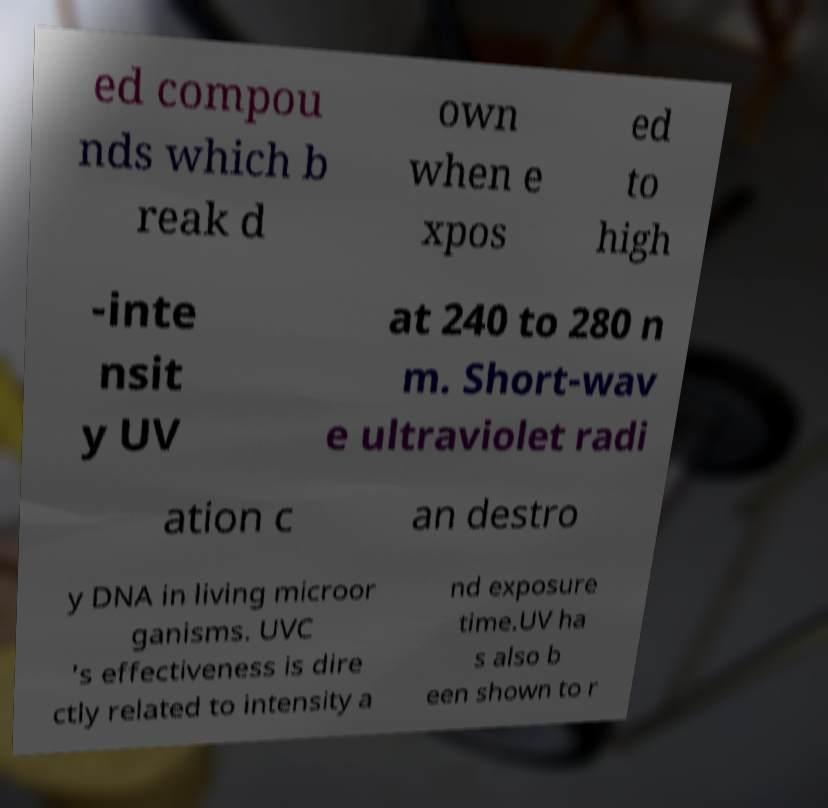Could you assist in decoding the text presented in this image and type it out clearly? ed compou nds which b reak d own when e xpos ed to high -inte nsit y UV at 240 to 280 n m. Short-wav e ultraviolet radi ation c an destro y DNA in living microor ganisms. UVC 's effectiveness is dire ctly related to intensity a nd exposure time.UV ha s also b een shown to r 